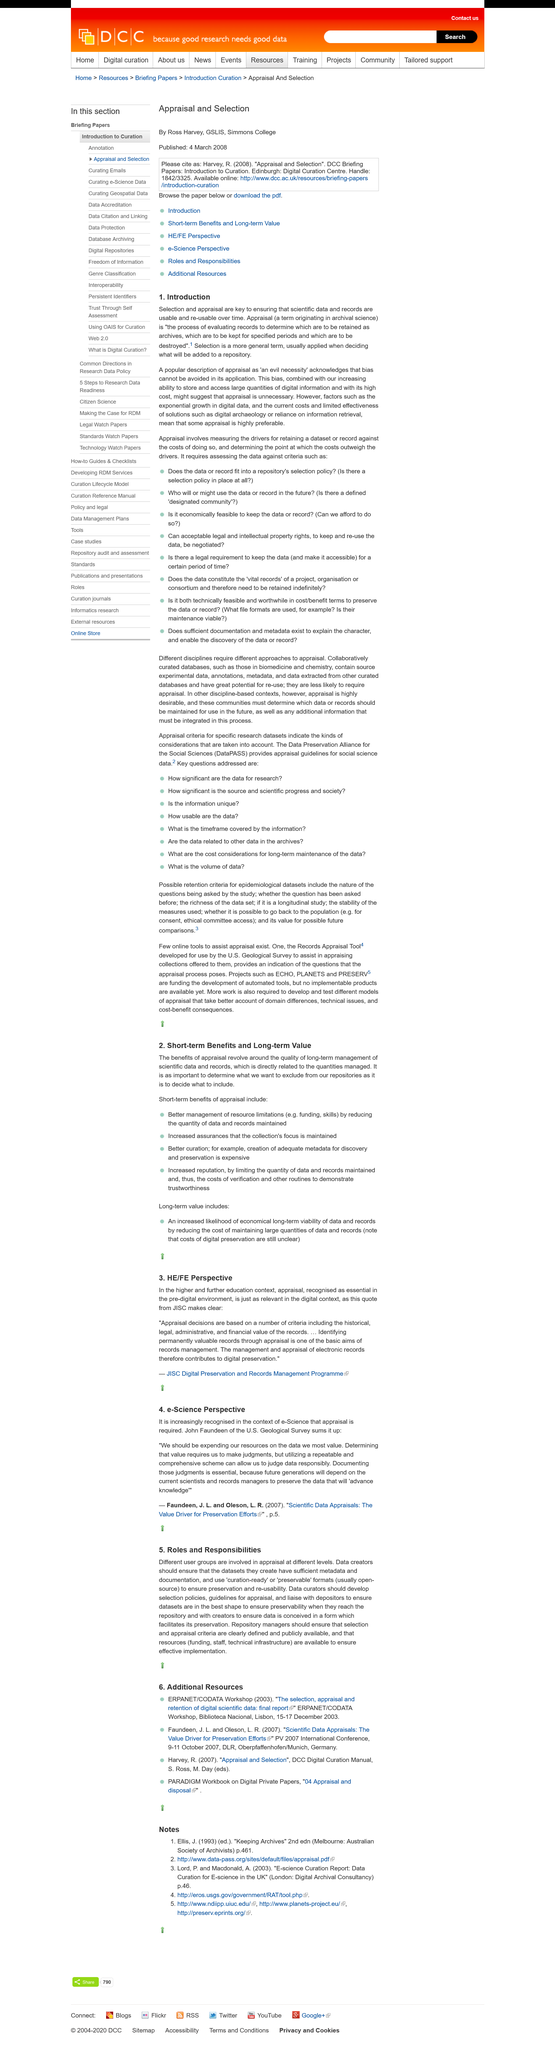Specify some key components in this picture. The term "appraisal" originates from archival science and is used to describe the process of evaluating the authenticity, reliability, and significance of historical documents and artifacts. Yes, there is a bias with the selection process. Selection and appraisal are key processes that ensure the usability of scientific data and records over time. 